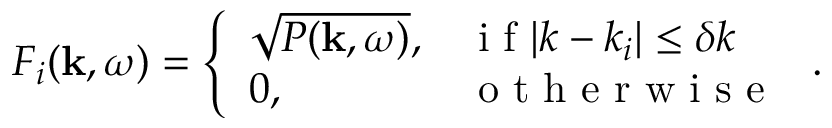<formula> <loc_0><loc_0><loc_500><loc_500>F _ { i } ( k , \omega ) = \left \{ \begin{array} { l l } { \sqrt { P ( k , \omega ) } , } & { i f | k - k _ { i } | \leq \delta k } \\ { 0 , } & { o t h e r w i s e } \end{array} .</formula> 